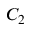Convert formula to latex. <formula><loc_0><loc_0><loc_500><loc_500>C _ { 2 }</formula> 